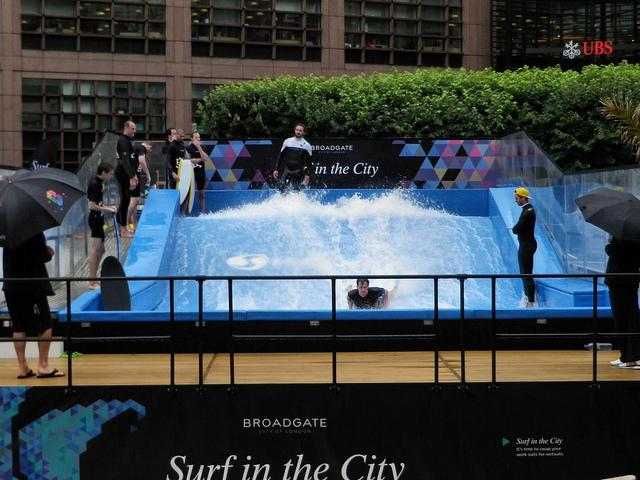What type of area is this event taking place at? Please explain your reasoning. city. The size of the many-windowed brown building in the background of this scene places it in a metro area. 